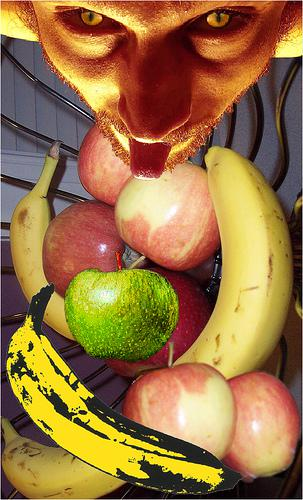Question: where is the overripe banana?
Choices:
A. On the counter.
B. Bottom center of photo.
C. On the banana holder.
D. In the bowl.
Answer with the letter. Answer: B Question: what material is the container of the fruit?
Choices:
A. Ceramic.
B. Plastic.
C. Metal.
D. Wood.
Answer with the letter. Answer: C Question: who is in the picture?
Choices:
A. Woman.
B. Man.
C. Girl.
D. Boy.
Answer with the letter. Answer: B 